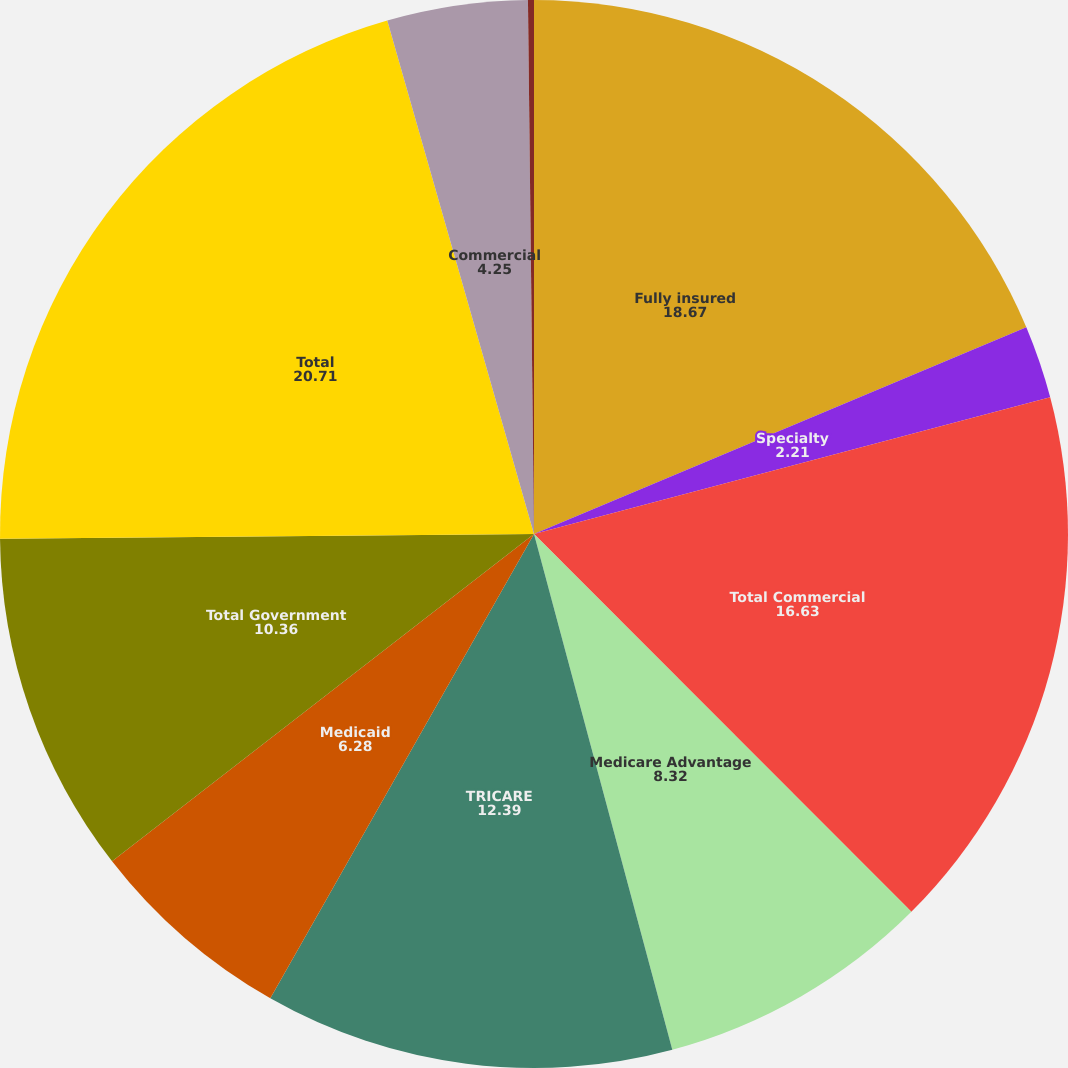Convert chart to OTSL. <chart><loc_0><loc_0><loc_500><loc_500><pie_chart><fcel>Fully insured<fcel>Specialty<fcel>Total Commercial<fcel>Medicare Advantage<fcel>TRICARE<fcel>Medicaid<fcel>Total Government<fcel>Total<fcel>Commercial<fcel>Government<nl><fcel>18.67%<fcel>2.21%<fcel>16.63%<fcel>8.32%<fcel>12.39%<fcel>6.28%<fcel>10.36%<fcel>20.71%<fcel>4.25%<fcel>0.18%<nl></chart> 